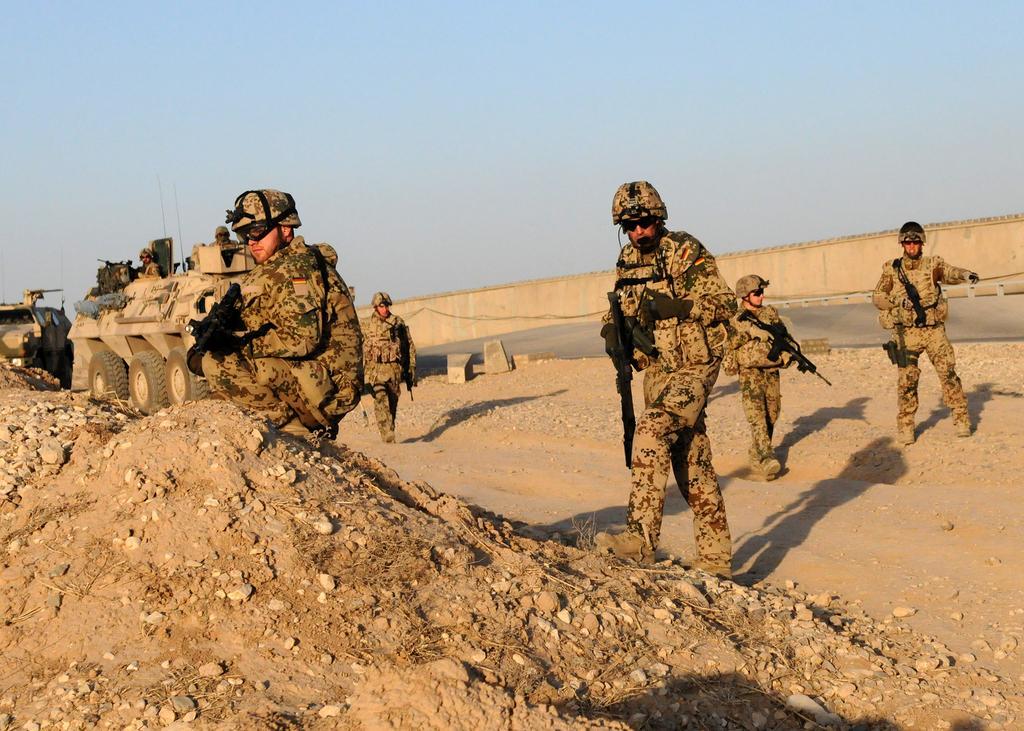Can you describe this image briefly? This picture is clicked outside. On the the left there is a person wearing uniform holding a rifle and seems to be squatting. On the right we can see the group of persons wearing uniforms, helmets, holding rifles and seems to be walking on the ground and we can see the gravels and the mud and we can see the the vehicles. In the background we can see the sky and some other objects. 